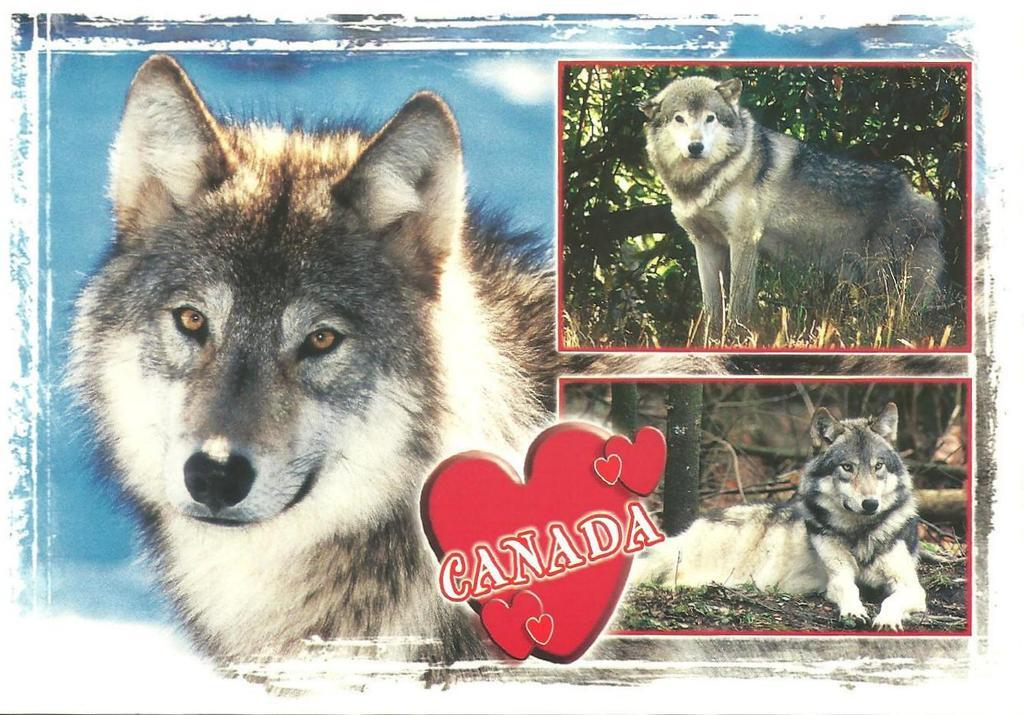What type of photo is the image? The image is a collage photo. What subject is featured in the collage photo? The collage photo contains three photos of a dog. Are there any words or phrases in the collage photo? Yes, there is text present in the collage photo. What type of yam is being displayed in the collage photo? There is no yam present in the collage photo; it features three photos of a dog and text. Can you see any exposed flesh in the collage photo? There is no exposed flesh visible in the collage photo; it contains three photos of a dog and text. 